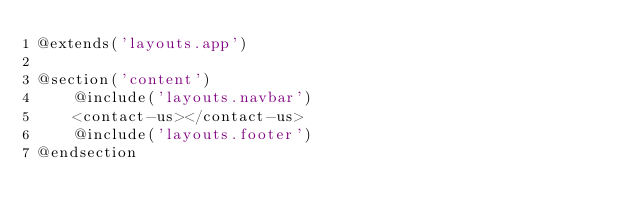Convert code to text. <code><loc_0><loc_0><loc_500><loc_500><_PHP_>@extends('layouts.app')

@section('content')
    @include('layouts.navbar')
    <contact-us></contact-us>
    @include('layouts.footer')
@endsection
</code> 